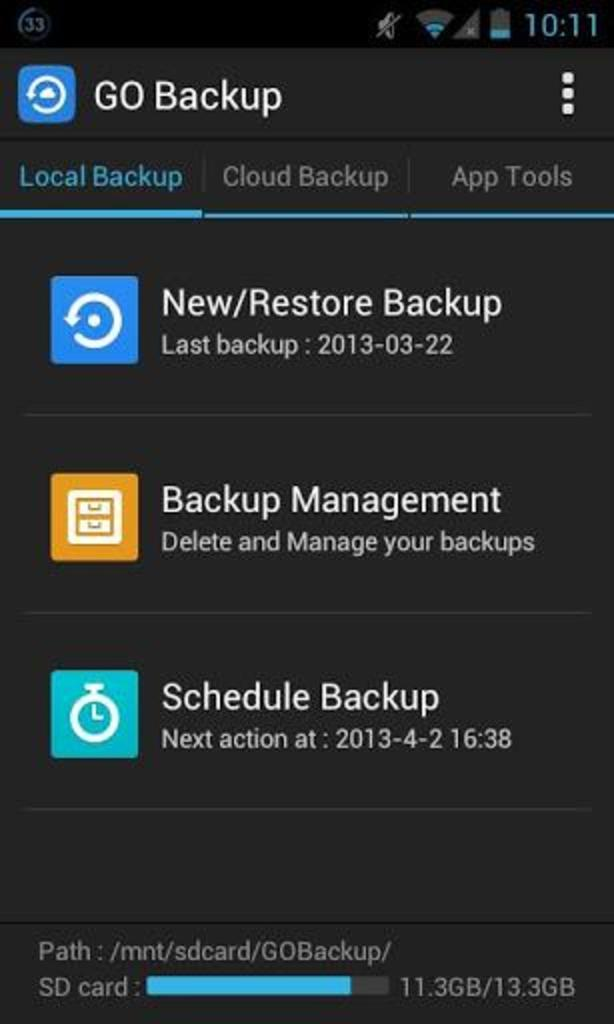<image>
Write a terse but informative summary of the picture. A screenshot on a phone of the last backup, dated march 22, 2013. 